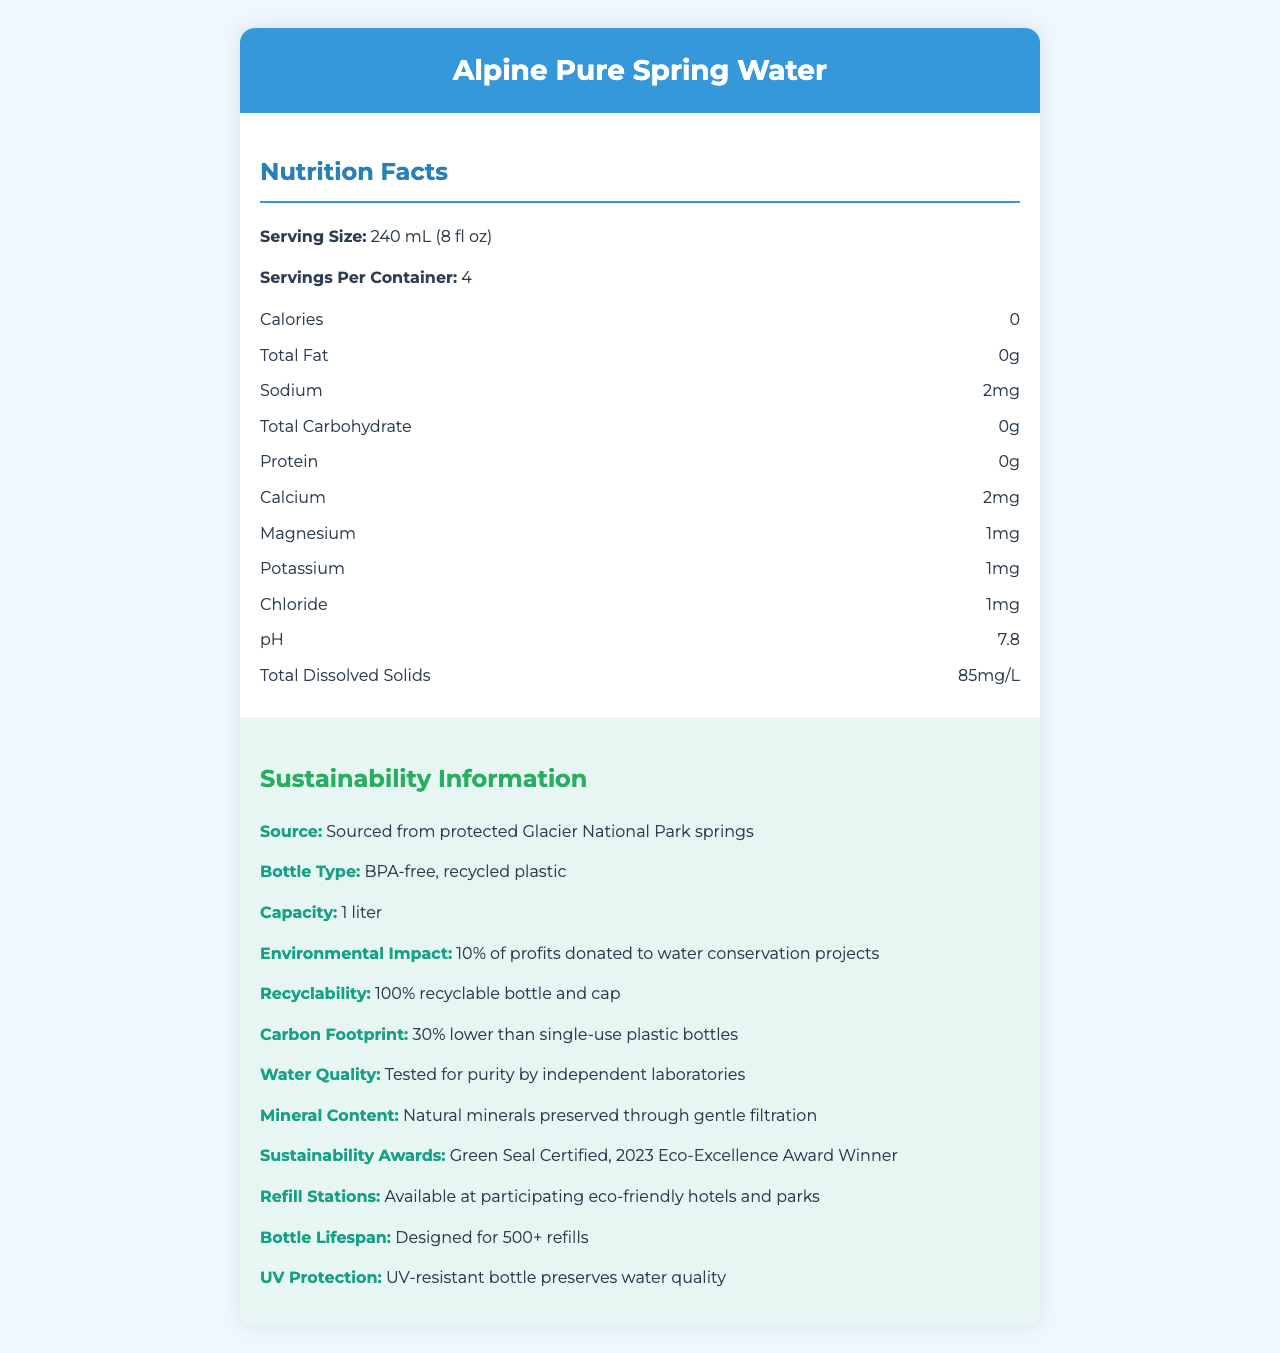what is the serving size? The serving size is directly mentioned in the nutrition facts section of the document.
Answer: 240 mL (8 fl oz) how many servings are in one container? The servings per container are clearly stated in the nutrition facts section.
Answer: 4 how many calories are in one serving? The calories per serving are listed as 0 in the nutrition facts section.
Answer: 0 what is the pH level of the water? The pH level is specifically indicated to be 7.8 in the nutrition facts section.
Answer: 7.8 what is the source of the water? This information is stated under the sustainability information as the source of the water.
Answer: Protected Glacier National Park springs What type of plastic is the bottle made of? The bottle type is listed as BPA-free, recycled plastic in the sustainability information section.
Answer: BPA-free, recycled plastic how much sodium is in one serving of the water? The amount of sodium per serving is stated in the nutrition facts section.
Answer: 2 mg how many minerals are preserved through the filtration of the water? The document specifies that natural minerals are preserved through gentle filtration in the sustainability information section.
Answer: Natural minerals how many refills is the bottle designed for? A. 100 B. 200 C. 500+ D. 1000+ The document states that the bottle is designed for 500+ refills.
Answer: C how much calcium is in one serving of the water? A. 1 mg B. 2 mg C. 5 mg D. 10 mg The nutrition facts section specifies that there is 2 mg of calcium per serving.
Answer: B is the water tested for purity by independent laboratories? The water quality testing information confirms that it is tested for purity by independent laboratories.
Answer: Yes is the bottle recyclable? The document specifies that the bottle and cap are 100% recyclable under the sustainability information.
Answer: Yes summarize the main sustainability efforts of the product. The document highlights several sustainability measures, including the type of materials used for the bottle, its recyclability, the environmental impact of the company's profits, and awards received for sustainability. It also provides information about the source of the water and refill stations.
Answer: The product, Alpine Pure Spring Water, emphasizes sustainability through the use of BPA-free, recycled plastic for the bottle, which is designed for 500+ refills and is 100% recyclable. The company donates 10% of profits to water conservation projects, and the product has received sustainability awards like the Green Seal Certified and 2023 Eco-Excellence Award. The water is sourced from protected Glacier National Park springs, and refill stations are available at participating eco-friendly hotels and parks. Additionally, the product's carbon footprint is 30% lower than single-use plastic bottles. is the nutritional information sufficient to determine daily value percentages? The document does not provide daily value percentages for nutrients, so it is not possible to determine the contribution of this product to the daily intake requirements.
Answer: No what awards has the product received? The sustainability information section lists the awards the product has received.
Answer: Green Seal Certified, 2023 Eco-Excellence Award Winner describe the environmental impact of purchasing this product. The document provides details about the company's environmental contributions and the reduced carbon footprint of the bottle.
Answer: 10% of the profits are donated to water conservation projects, and the bottle's carbon footprint is 30% lower than single-use plastic bottles. is the water alkaline, neutral, or acidic? The pH level is 7.8, which is slightly alkaline.
Answer: Alkaline 